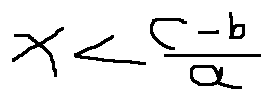Convert formula to latex. <formula><loc_0><loc_0><loc_500><loc_500>x < \frac { c - b } { a }</formula> 